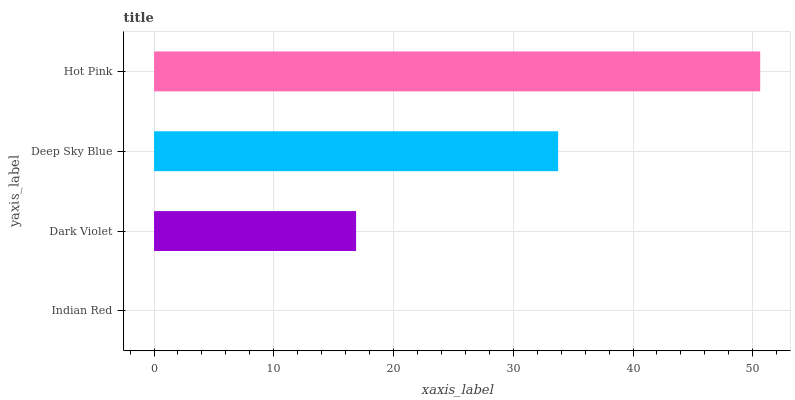Is Indian Red the minimum?
Answer yes or no. Yes. Is Hot Pink the maximum?
Answer yes or no. Yes. Is Dark Violet the minimum?
Answer yes or no. No. Is Dark Violet the maximum?
Answer yes or no. No. Is Dark Violet greater than Indian Red?
Answer yes or no. Yes. Is Indian Red less than Dark Violet?
Answer yes or no. Yes. Is Indian Red greater than Dark Violet?
Answer yes or no. No. Is Dark Violet less than Indian Red?
Answer yes or no. No. Is Deep Sky Blue the high median?
Answer yes or no. Yes. Is Dark Violet the low median?
Answer yes or no. Yes. Is Dark Violet the high median?
Answer yes or no. No. Is Hot Pink the low median?
Answer yes or no. No. 